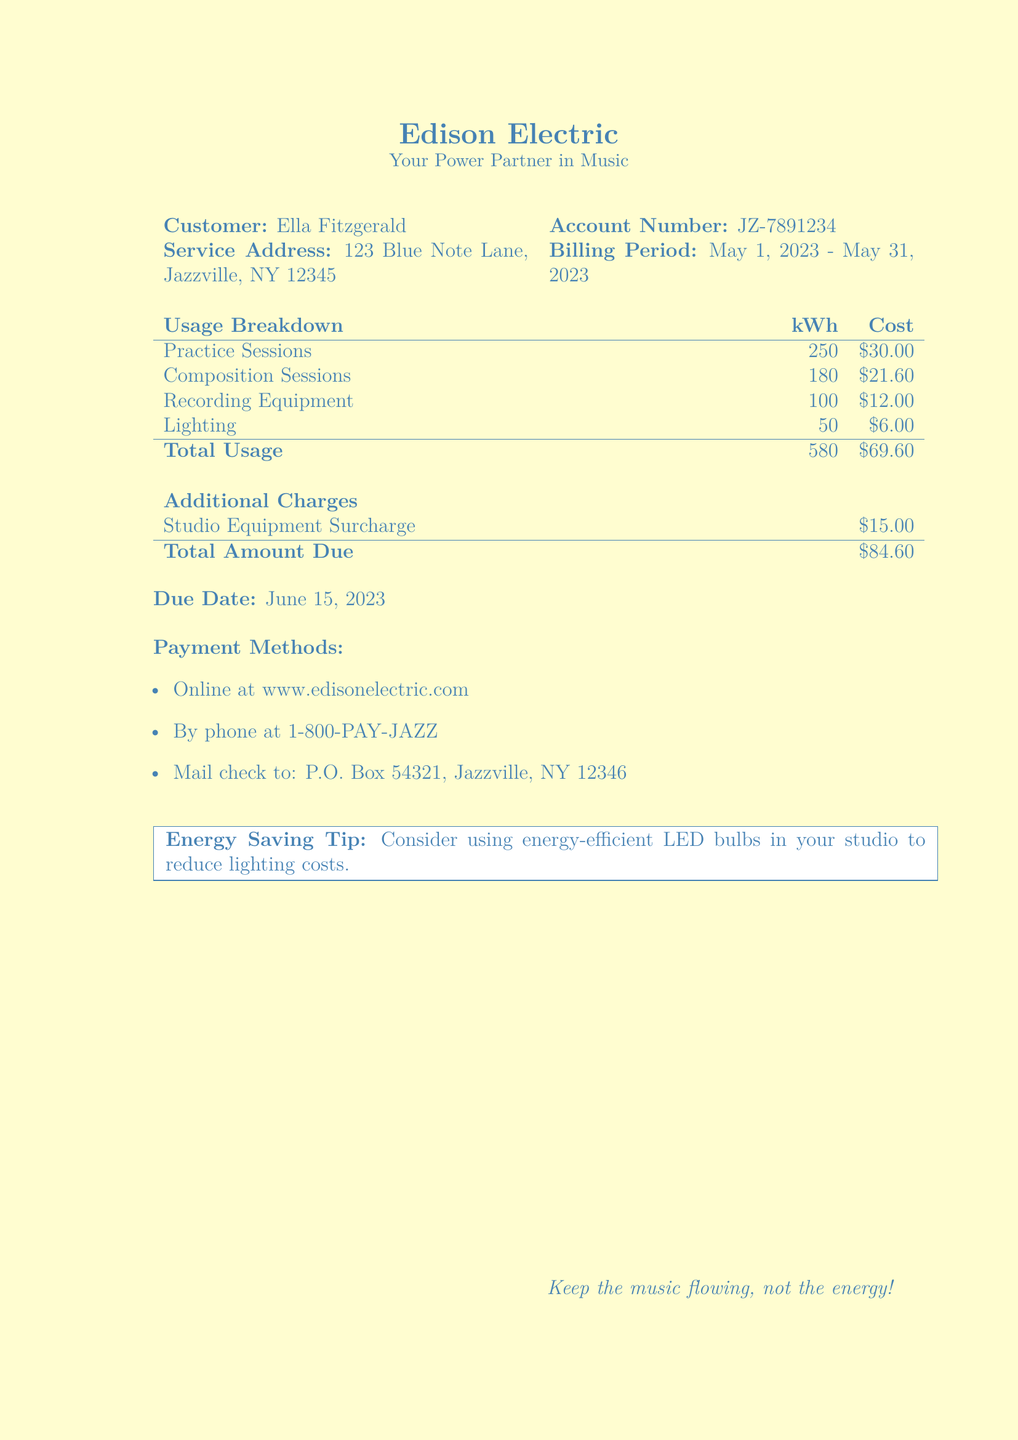what is the billing period? The billing period is indicated in the document under "Billing Period," which shows the dates of service.
Answer: May 1, 2023 - May 31, 2023 who is the customer? The customer's name is shown at the top of the document.
Answer: Ella Fitzgerald what is the total usage in kilowatt-hours? The total usage can be found at the bottom of the usage breakdown table, summarizing all electricity used.
Answer: 580 how much did the practice sessions cost? The cost for practice sessions is specified in the usage breakdown section of the document.
Answer: $30.00 what is the total amount due? The total amount due is clearly stated at the end of the document, including all charges.
Answer: $84.60 what is the due date for the payment? The due date is mentioned in the document to inform the customer when payment is expected.
Answer: June 15, 2023 how much is the studio equipment surcharge? The surcharge can be found in the additional charges section of the bill.
Answer: $15.00 what is the cost for lighting? The cost for lighting is detailed in the usage breakdown table.
Answer: $6.00 what payment methods are offered? The payment methods section lists various ways to pay the bill, and this is unique to bill documents.
Answer: Online, by phone, mail check 